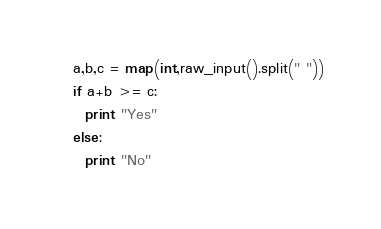Convert code to text. <code><loc_0><loc_0><loc_500><loc_500><_Python_>a,b,c = map(int,raw_input().split(" "))
if a+b >= c:
  print "Yes"
else:
  print "No"</code> 